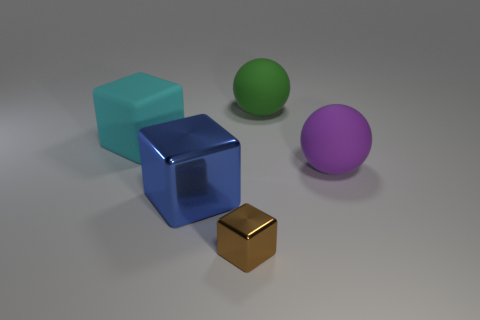Subtract all gray balls. Subtract all red cylinders. How many balls are left? 2 Add 4 tiny cyan metal spheres. How many objects exist? 9 Subtract all blocks. How many objects are left? 2 Add 3 blue things. How many blue things exist? 4 Subtract 0 gray cubes. How many objects are left? 5 Subtract all small cyan metal things. Subtract all large blue cubes. How many objects are left? 4 Add 5 cyan matte objects. How many cyan matte objects are left? 6 